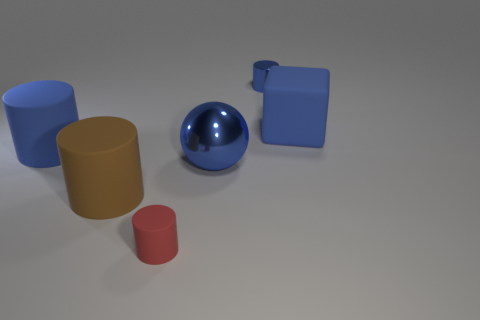What is the size of the blue cylinder in front of the cube?
Make the answer very short. Large. There is a big block; is it the same color as the cylinder behind the big blue cube?
Offer a terse response. Yes. Is there a thing that has the same color as the ball?
Offer a terse response. Yes. Do the red thing and the blue cylinder that is right of the metal sphere have the same material?
Provide a short and direct response. No. How many large things are either purple balls or blue cubes?
Offer a very short reply. 1. There is a ball that is the same color as the metallic cylinder; what material is it?
Offer a terse response. Metal. Is the number of big metallic balls less than the number of large purple rubber spheres?
Your answer should be very brief. No. Does the cylinder behind the big blue matte block have the same size as the blue rubber thing left of the red rubber thing?
Ensure brevity in your answer.  No. How many red things are either cylinders or cubes?
Your answer should be compact. 1. There is a metallic sphere that is the same color as the small shiny object; what size is it?
Keep it short and to the point. Large. 